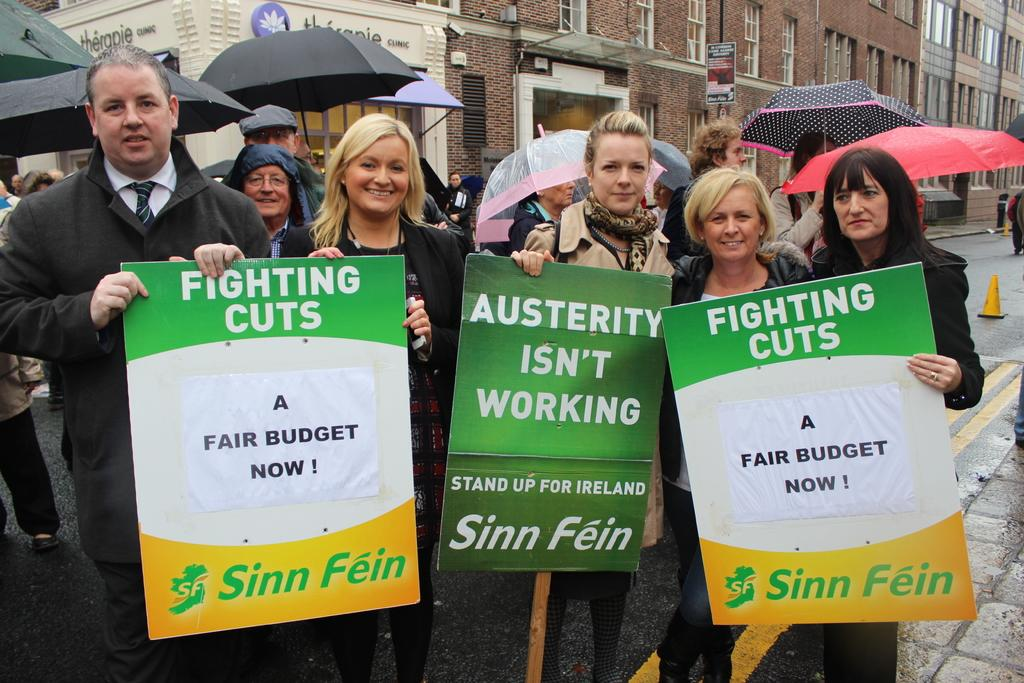What are the people on the road doing? The people are standing on the road and holding boards. Are there any other objects or items being held by the people? Yes, there are people holding umbrellas. What can be seen in the background? There are buildings in the background. What feature of the buildings can be observed? The buildings have windows. How many pizzas are being delivered in the image? There are no pizzas visible in the image. 